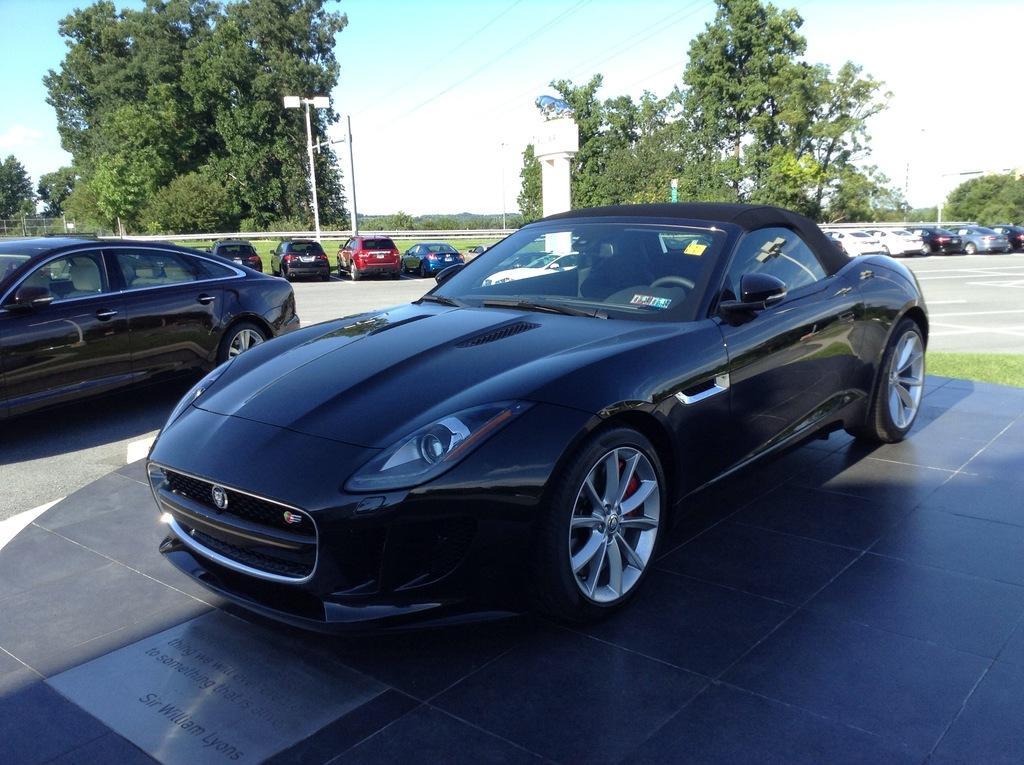Describe this image in one or two sentences. In this image I can see few cars. I can see some grass on the ground. I can see few trees. I can see few poles. At the top I can see the sky. 